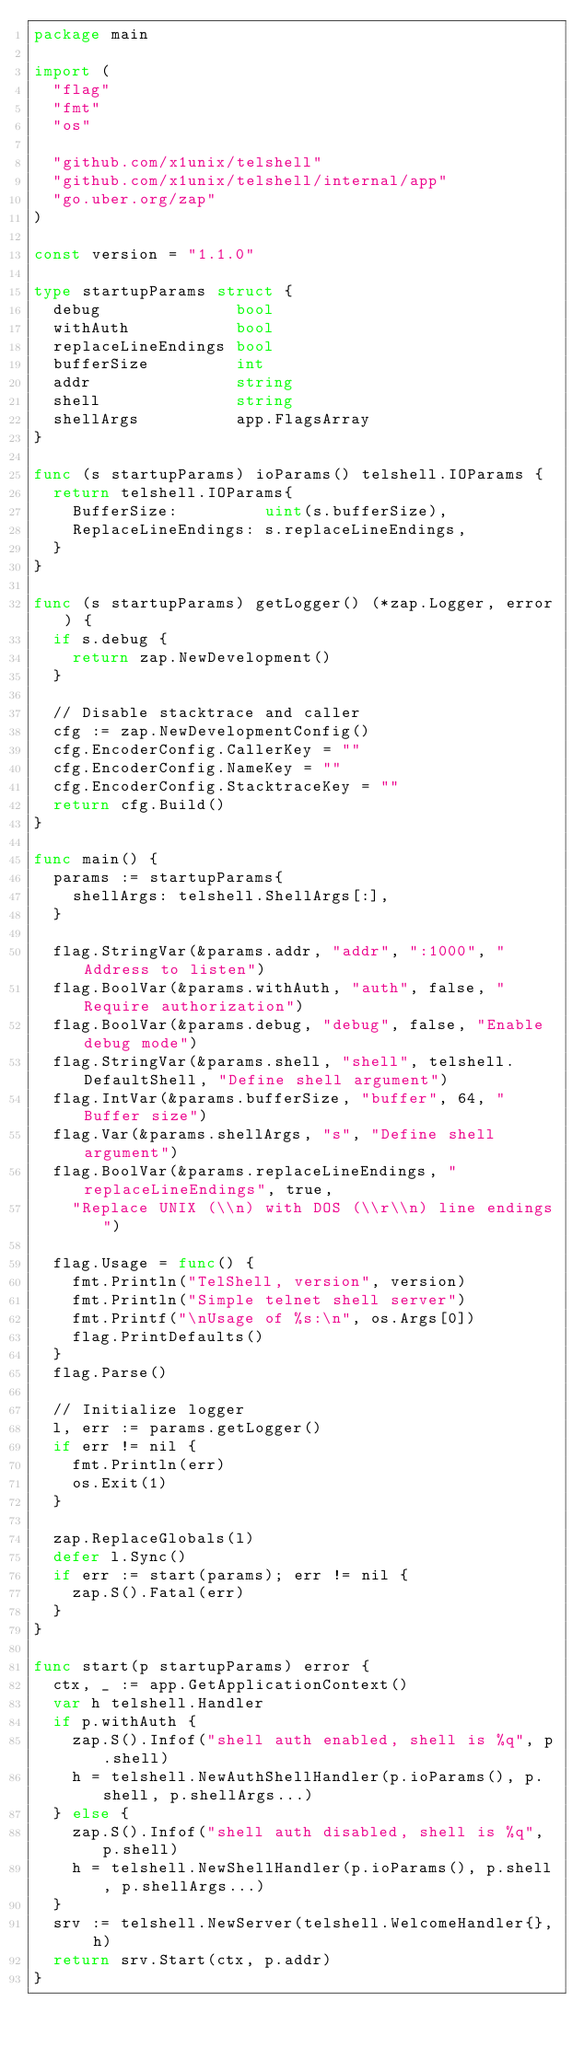Convert code to text. <code><loc_0><loc_0><loc_500><loc_500><_Go_>package main

import (
	"flag"
	"fmt"
	"os"

	"github.com/x1unix/telshell"
	"github.com/x1unix/telshell/internal/app"
	"go.uber.org/zap"
)

const version = "1.1.0"

type startupParams struct {
	debug              bool
	withAuth           bool
	replaceLineEndings bool
	bufferSize         int
	addr               string
	shell              string
	shellArgs          app.FlagsArray
}

func (s startupParams) ioParams() telshell.IOParams {
	return telshell.IOParams{
		BufferSize:         uint(s.bufferSize),
		ReplaceLineEndings: s.replaceLineEndings,
	}
}

func (s startupParams) getLogger() (*zap.Logger, error) {
	if s.debug {
		return zap.NewDevelopment()
	}

	// Disable stacktrace and caller
	cfg := zap.NewDevelopmentConfig()
	cfg.EncoderConfig.CallerKey = ""
	cfg.EncoderConfig.NameKey = ""
	cfg.EncoderConfig.StacktraceKey = ""
	return cfg.Build()
}

func main() {
	params := startupParams{
		shellArgs: telshell.ShellArgs[:],
	}

	flag.StringVar(&params.addr, "addr", ":1000", "Address to listen")
	flag.BoolVar(&params.withAuth, "auth", false, "Require authorization")
	flag.BoolVar(&params.debug, "debug", false, "Enable debug mode")
	flag.StringVar(&params.shell, "shell", telshell.DefaultShell, "Define shell argument")
	flag.IntVar(&params.bufferSize, "buffer", 64, "Buffer size")
	flag.Var(&params.shellArgs, "s", "Define shell argument")
	flag.BoolVar(&params.replaceLineEndings, "replaceLineEndings", true,
		"Replace UNIX (\\n) with DOS (\\r\\n) line endings")

	flag.Usage = func() {
		fmt.Println("TelShell, version", version)
		fmt.Println("Simple telnet shell server")
		fmt.Printf("\nUsage of %s:\n", os.Args[0])
		flag.PrintDefaults()
	}
	flag.Parse()

	// Initialize logger
	l, err := params.getLogger()
	if err != nil {
		fmt.Println(err)
		os.Exit(1)
	}

	zap.ReplaceGlobals(l)
	defer l.Sync()
	if err := start(params); err != nil {
		zap.S().Fatal(err)
	}
}

func start(p startupParams) error {
	ctx, _ := app.GetApplicationContext()
	var h telshell.Handler
	if p.withAuth {
		zap.S().Infof("shell auth enabled, shell is %q", p.shell)
		h = telshell.NewAuthShellHandler(p.ioParams(), p.shell, p.shellArgs...)
	} else {
		zap.S().Infof("shell auth disabled, shell is %q", p.shell)
		h = telshell.NewShellHandler(p.ioParams(), p.shell, p.shellArgs...)
	}
	srv := telshell.NewServer(telshell.WelcomeHandler{}, h)
	return srv.Start(ctx, p.addr)
}
</code> 